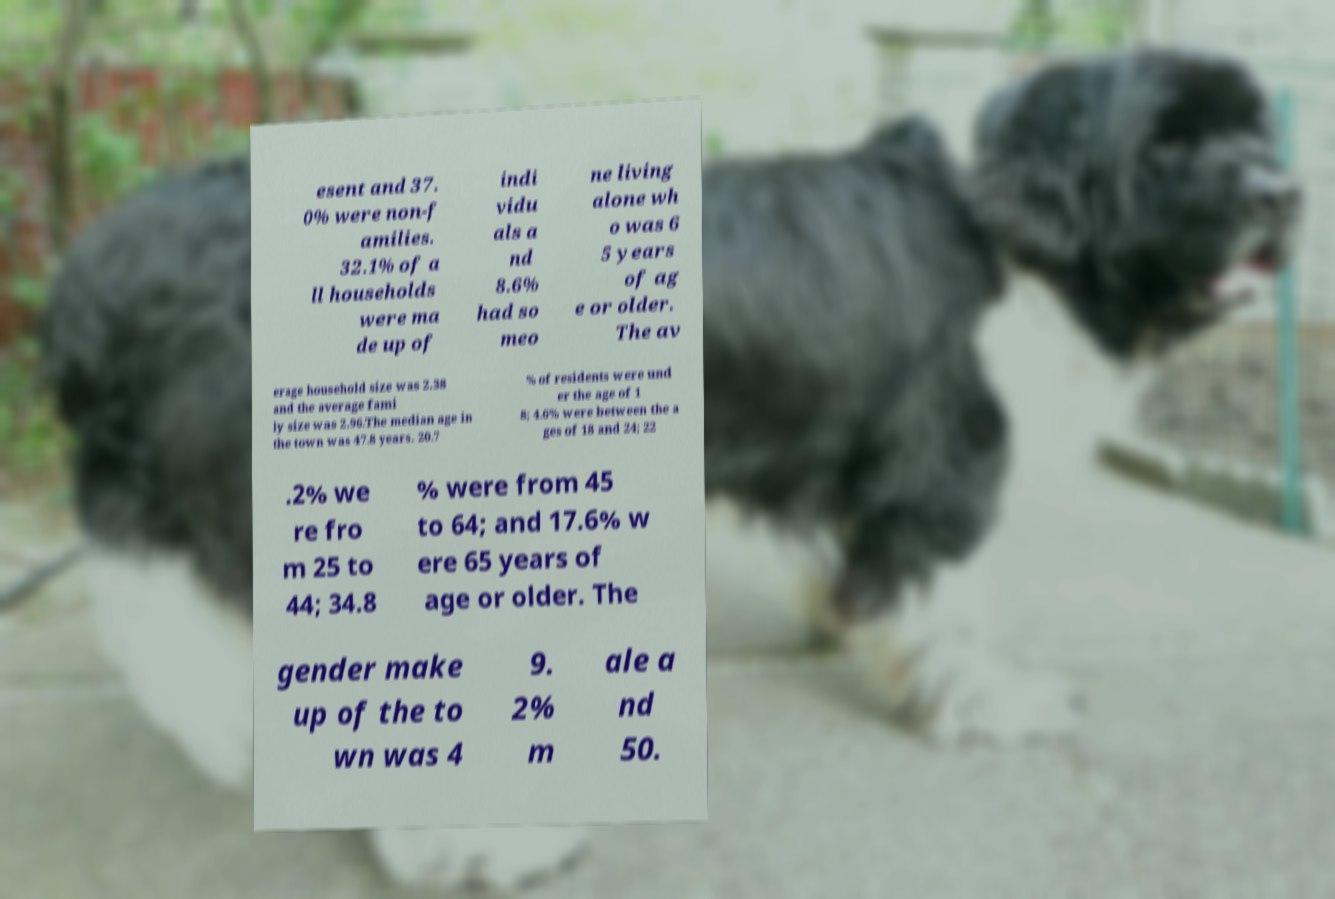Could you extract and type out the text from this image? esent and 37. 0% were non-f amilies. 32.1% of a ll households were ma de up of indi vidu als a nd 8.6% had so meo ne living alone wh o was 6 5 years of ag e or older. The av erage household size was 2.38 and the average fami ly size was 2.96.The median age in the town was 47.8 years. 20.7 % of residents were und er the age of 1 8; 4.6% were between the a ges of 18 and 24; 22 .2% we re fro m 25 to 44; 34.8 % were from 45 to 64; and 17.6% w ere 65 years of age or older. The gender make up of the to wn was 4 9. 2% m ale a nd 50. 